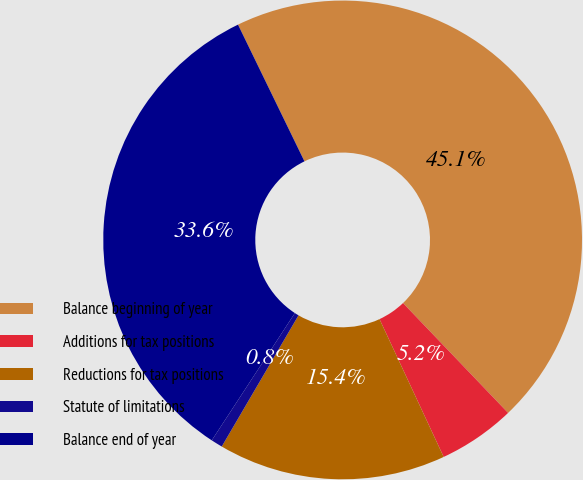Convert chart. <chart><loc_0><loc_0><loc_500><loc_500><pie_chart><fcel>Balance beginning of year<fcel>Additions for tax positions<fcel>Reductions for tax positions<fcel>Statute of limitations<fcel>Balance end of year<nl><fcel>45.05%<fcel>5.21%<fcel>15.36%<fcel>0.78%<fcel>33.59%<nl></chart> 